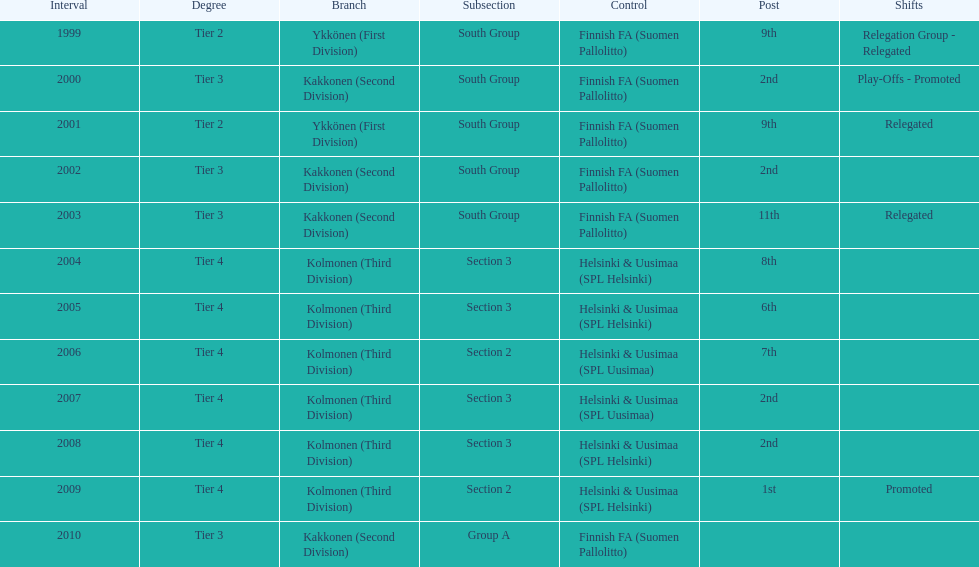I'm looking to parse the entire table for insights. Could you assist me with that? {'header': ['Interval', 'Degree', 'Branch', 'Subsection', 'Control', 'Post', 'Shifts'], 'rows': [['1999', 'Tier 2', 'Ykkönen (First Division)', 'South Group', 'Finnish FA (Suomen Pallolitto)', '9th', 'Relegation Group - Relegated'], ['2000', 'Tier 3', 'Kakkonen (Second Division)', 'South Group', 'Finnish FA (Suomen Pallolitto)', '2nd', 'Play-Offs - Promoted'], ['2001', 'Tier 2', 'Ykkönen (First Division)', 'South Group', 'Finnish FA (Suomen Pallolitto)', '9th', 'Relegated'], ['2002', 'Tier 3', 'Kakkonen (Second Division)', 'South Group', 'Finnish FA (Suomen Pallolitto)', '2nd', ''], ['2003', 'Tier 3', 'Kakkonen (Second Division)', 'South Group', 'Finnish FA (Suomen Pallolitto)', '11th', 'Relegated'], ['2004', 'Tier 4', 'Kolmonen (Third Division)', 'Section 3', 'Helsinki & Uusimaa (SPL Helsinki)', '8th', ''], ['2005', 'Tier 4', 'Kolmonen (Third Division)', 'Section 3', 'Helsinki & Uusimaa (SPL Helsinki)', '6th', ''], ['2006', 'Tier 4', 'Kolmonen (Third Division)', 'Section 2', 'Helsinki & Uusimaa (SPL Uusimaa)', '7th', ''], ['2007', 'Tier 4', 'Kolmonen (Third Division)', 'Section 3', 'Helsinki & Uusimaa (SPL Uusimaa)', '2nd', ''], ['2008', 'Tier 4', 'Kolmonen (Third Division)', 'Section 3', 'Helsinki & Uusimaa (SPL Helsinki)', '2nd', ''], ['2009', 'Tier 4', 'Kolmonen (Third Division)', 'Section 2', 'Helsinki & Uusimaa (SPL Helsinki)', '1st', 'Promoted'], ['2010', 'Tier 3', 'Kakkonen (Second Division)', 'Group A', 'Finnish FA (Suomen Pallolitto)', '', '']]} Of the third division, how many were in section3? 4. 